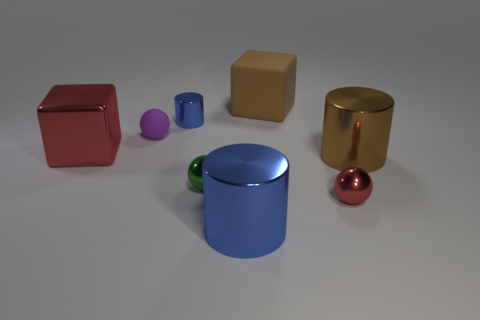Add 1 large green rubber cylinders. How many objects exist? 9 Subtract all cylinders. How many objects are left? 5 Subtract all small spheres. Subtract all green objects. How many objects are left? 4 Add 7 purple matte balls. How many purple matte balls are left? 8 Add 8 blocks. How many blocks exist? 10 Subtract 0 yellow cubes. How many objects are left? 8 